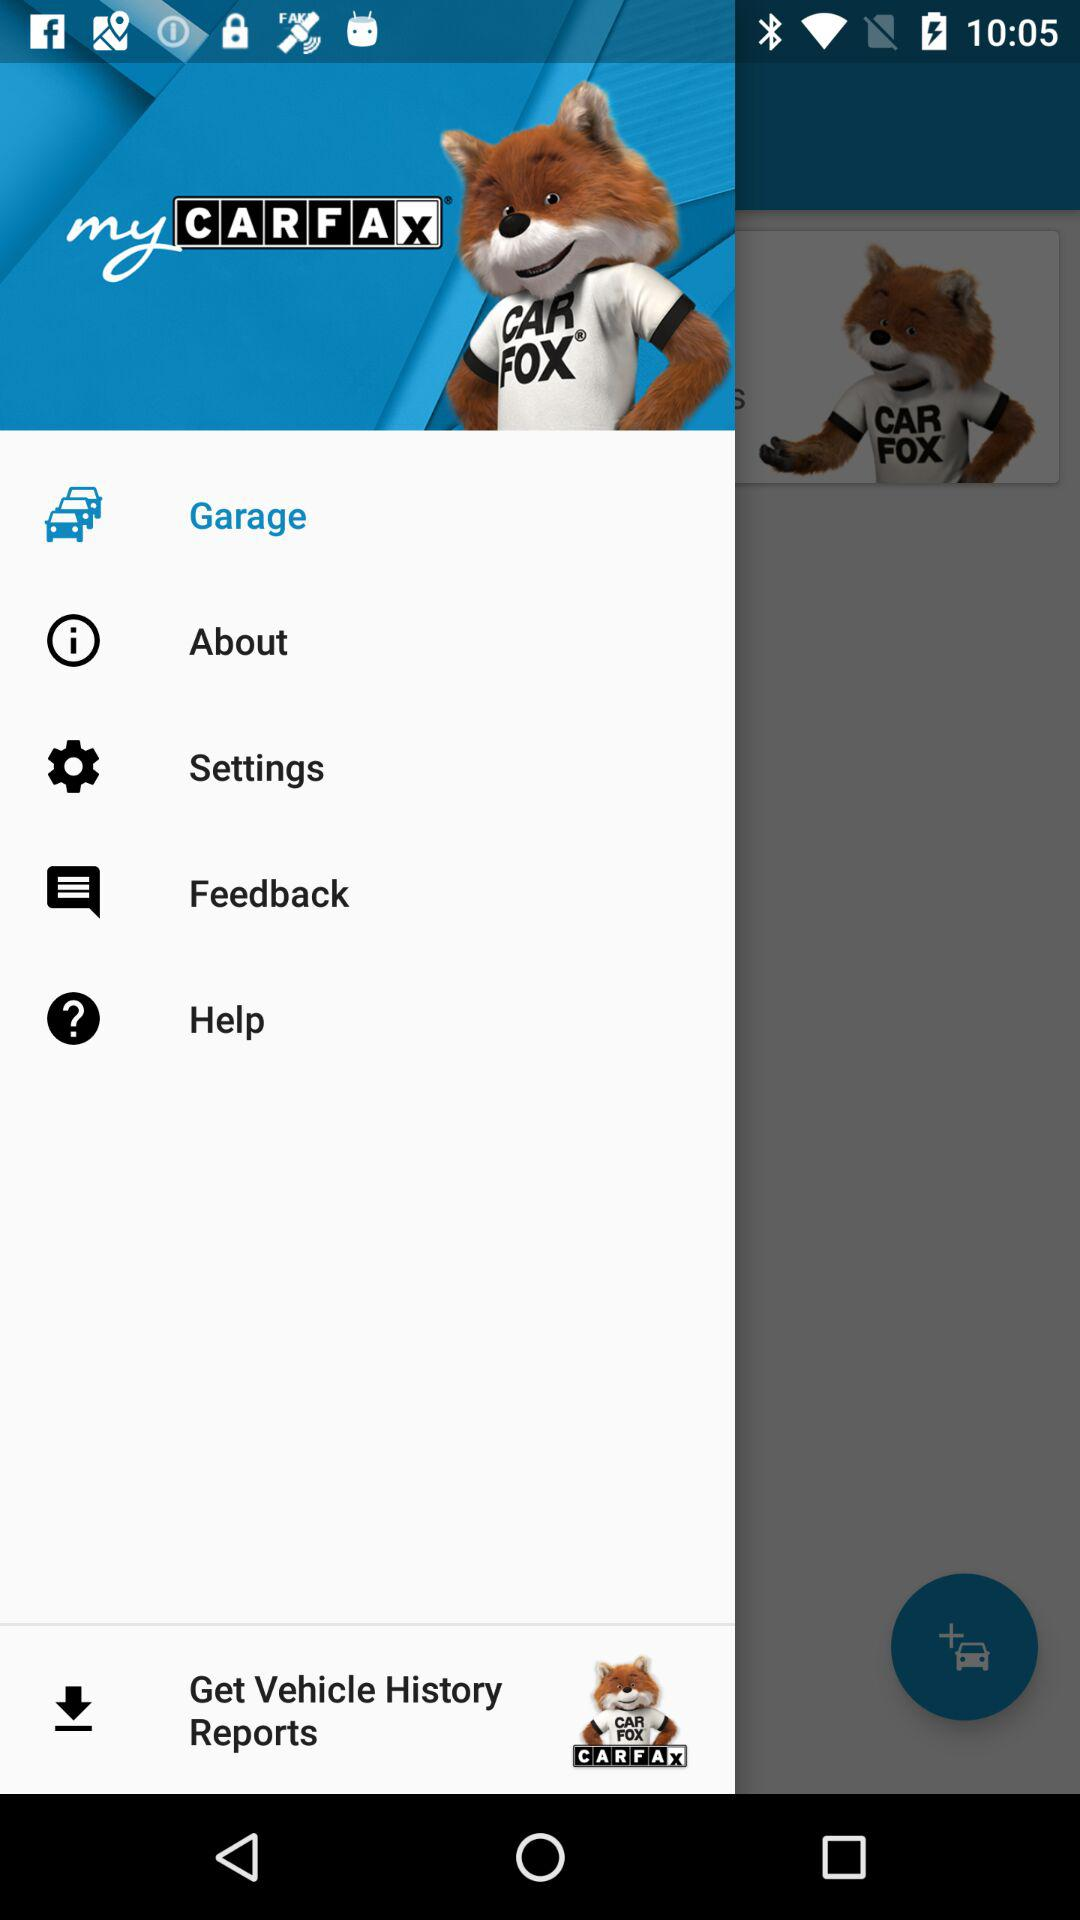What is the application name? The application name is "myCARFAX". 